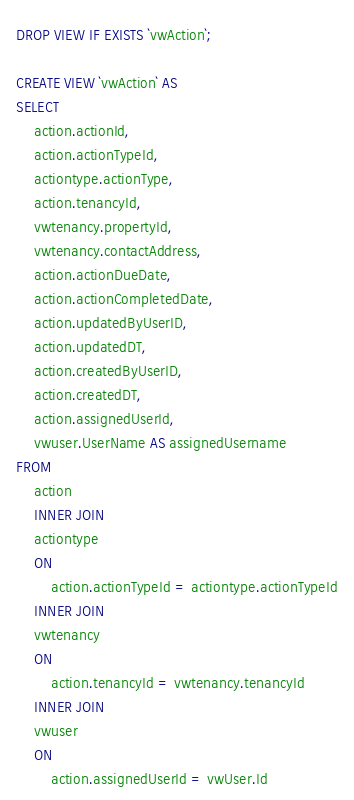Convert code to text. <code><loc_0><loc_0><loc_500><loc_500><_SQL_>DROP VIEW IF EXISTS `vwAction`;

CREATE VIEW `vwAction` AS
SELECT
	action.actionId, 
	action.actionTypeId, 
	actiontype.actionType, 
	action.tenancyId, 
	vwtenancy.propertyId,
	vwtenancy.contactAddress, 
	action.actionDueDate, 
	action.actionCompletedDate, 
	action.updatedByUserID, 
	action.updatedDT, 
	action.createdByUserID, 
	action.createdDT, 
	action.assignedUserId,
	vwuser.UserName AS assignedUsername
FROM
	action
	INNER JOIN
	actiontype
	ON 
		action.actionTypeId = actiontype.actionTypeId
	INNER JOIN
	vwtenancy
	ON 
		action.tenancyId = vwtenancy.tenancyId
	INNER JOIN
	vwuser
	ON
		action.assignedUserId = vwUser.Id</code> 